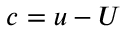<formula> <loc_0><loc_0><loc_500><loc_500>c = u - U</formula> 